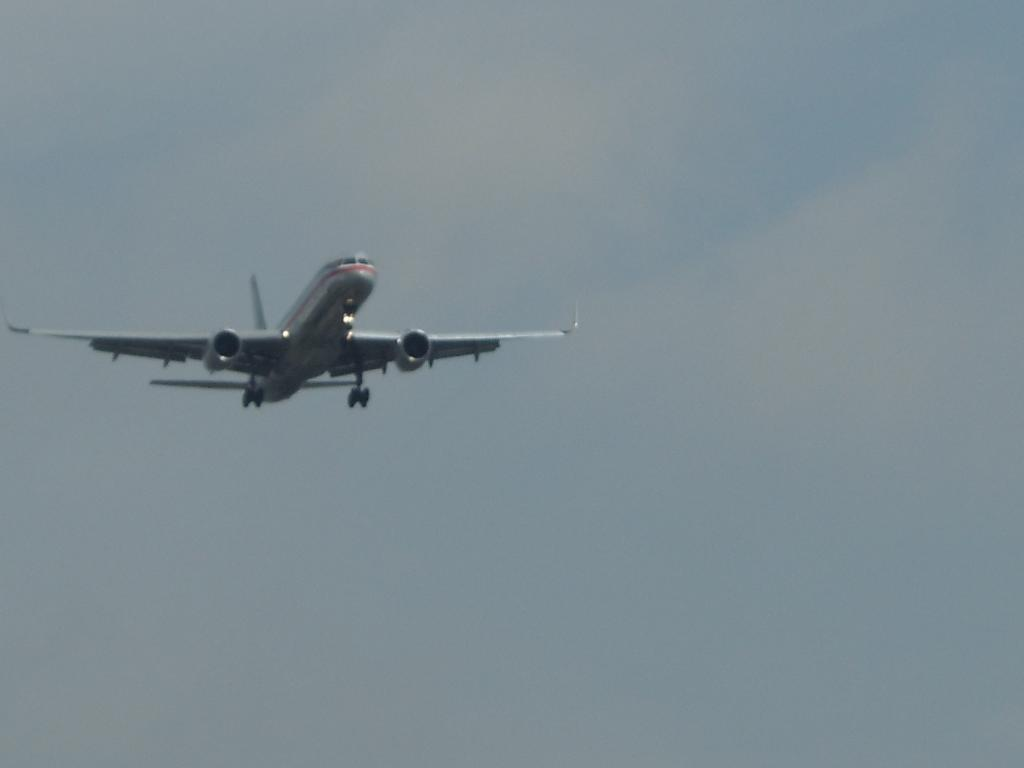What is the main subject of the image? The main subject of the image is an aircraft. What colors can be seen on the aircraft? The aircraft is white and red in color. What is the aircraft doing in the image? The aircraft is flying in the air. What can be seen in the background of the image? The sky is visible in the background of the image. What type of notebook is being used by the aircraft in the image? There is no notebook present in the image, as the main subject is an aircraft flying in the air. 